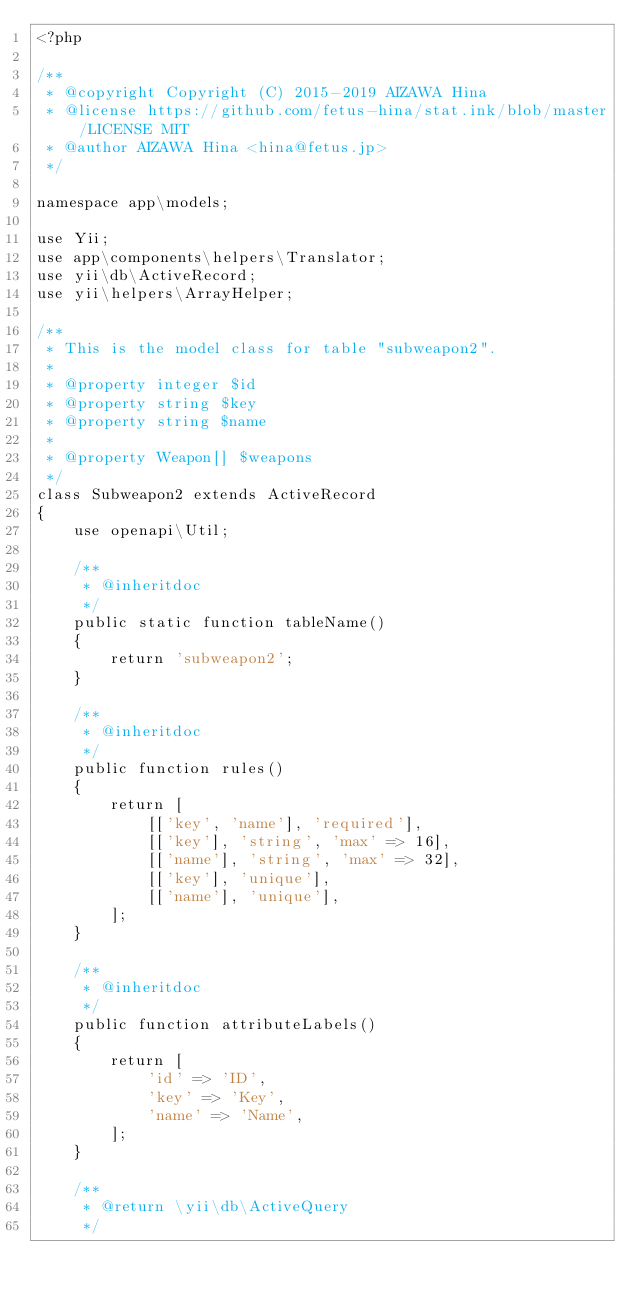<code> <loc_0><loc_0><loc_500><loc_500><_PHP_><?php

/**
 * @copyright Copyright (C) 2015-2019 AIZAWA Hina
 * @license https://github.com/fetus-hina/stat.ink/blob/master/LICENSE MIT
 * @author AIZAWA Hina <hina@fetus.jp>
 */

namespace app\models;

use Yii;
use app\components\helpers\Translator;
use yii\db\ActiveRecord;
use yii\helpers\ArrayHelper;

/**
 * This is the model class for table "subweapon2".
 *
 * @property integer $id
 * @property string $key
 * @property string $name
 *
 * @property Weapon[] $weapons
 */
class Subweapon2 extends ActiveRecord
{
    use openapi\Util;

    /**
     * @inheritdoc
     */
    public static function tableName()
    {
        return 'subweapon2';
    }

    /**
     * @inheritdoc
     */
    public function rules()
    {
        return [
            [['key', 'name'], 'required'],
            [['key'], 'string', 'max' => 16],
            [['name'], 'string', 'max' => 32],
            [['key'], 'unique'],
            [['name'], 'unique'],
        ];
    }

    /**
     * @inheritdoc
     */
    public function attributeLabels()
    {
        return [
            'id' => 'ID',
            'key' => 'Key',
            'name' => 'Name',
        ];
    }

    /**
     * @return \yii\db\ActiveQuery
     */</code> 